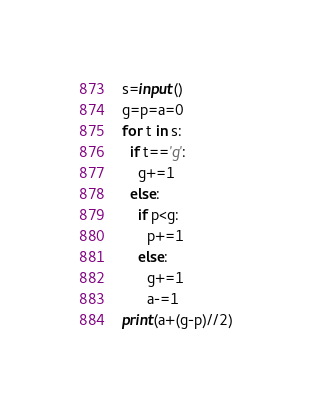Convert code to text. <code><loc_0><loc_0><loc_500><loc_500><_Python_>s=input()
g=p=a=0
for t in s:
  if t=='g':
    g+=1
  else:
    if p<g:
      p+=1
    else:
      g+=1
      a-=1
print(a+(g-p)//2)</code> 